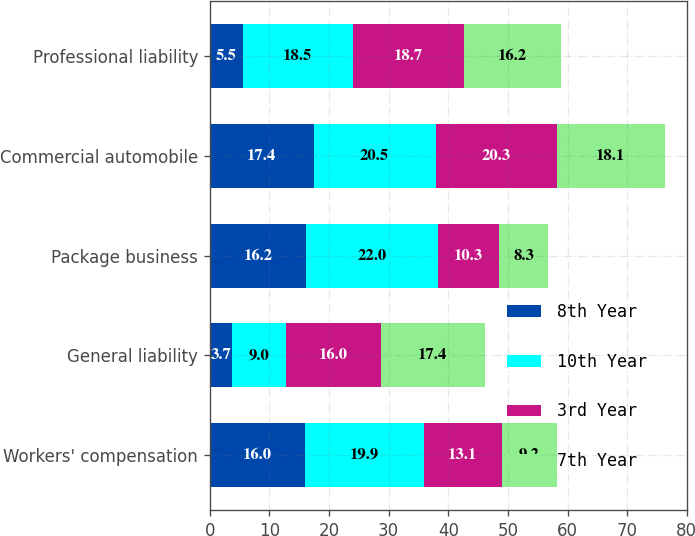<chart> <loc_0><loc_0><loc_500><loc_500><stacked_bar_chart><ecel><fcel>Workers' compensation<fcel>General liability<fcel>Package business<fcel>Commercial automobile<fcel>Professional liability<nl><fcel>8th Year<fcel>16<fcel>3.7<fcel>16.2<fcel>17.4<fcel>5.5<nl><fcel>10th Year<fcel>19.9<fcel>9<fcel>22<fcel>20.5<fcel>18.5<nl><fcel>3rd Year<fcel>13.1<fcel>16<fcel>10.3<fcel>20.3<fcel>18.7<nl><fcel>7th Year<fcel>9.2<fcel>17.4<fcel>8.3<fcel>18.1<fcel>16.2<nl></chart> 